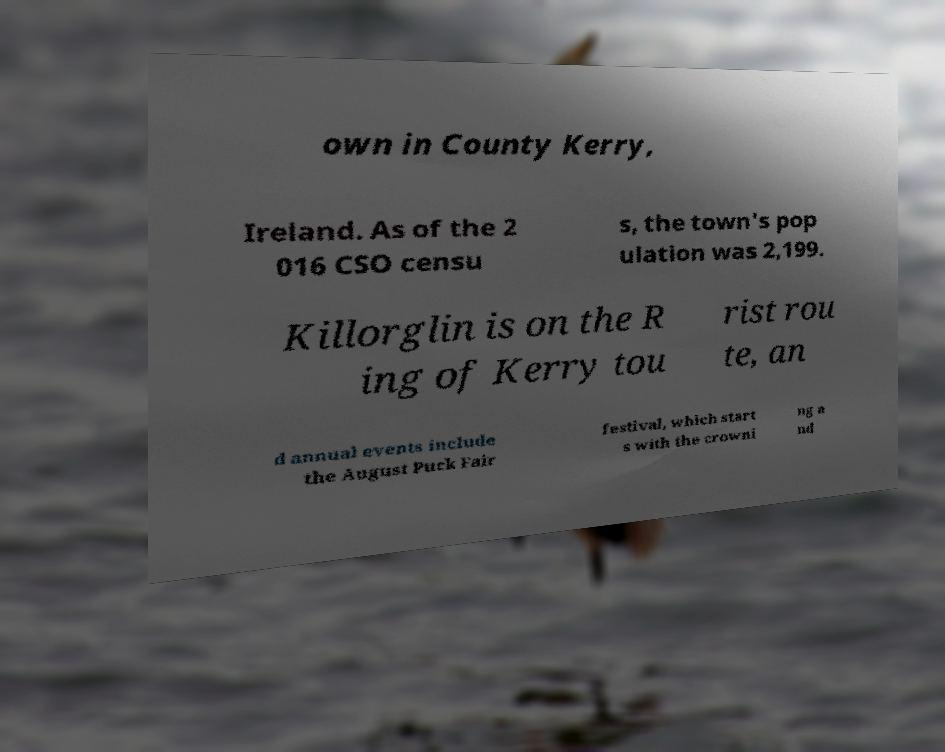Please identify and transcribe the text found in this image. own in County Kerry, Ireland. As of the 2 016 CSO censu s, the town's pop ulation was 2,199. Killorglin is on the R ing of Kerry tou rist rou te, an d annual events include the August Puck Fair festival, which start s with the crowni ng a nd 